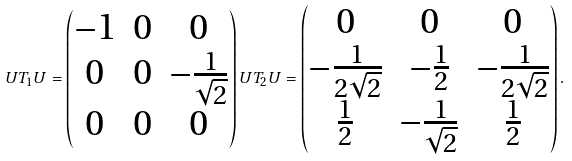<formula> <loc_0><loc_0><loc_500><loc_500>U T _ { 1 } U = \begin{pmatrix} - 1 & 0 & 0 \\ 0 & 0 & - \frac { 1 } { \sqrt { 2 } } \\ 0 & 0 & 0 \end{pmatrix} U T _ { 2 } U = \begin{pmatrix} 0 & 0 & 0 \\ - \frac { 1 } { 2 \sqrt { 2 } } & - \frac { 1 } { 2 } & - \frac { 1 } { 2 \sqrt { 2 } } \\ \frac { 1 } { 2 } & - \frac { 1 } { \sqrt { 2 } } & \frac { 1 } { 2 } \end{pmatrix} .</formula> 